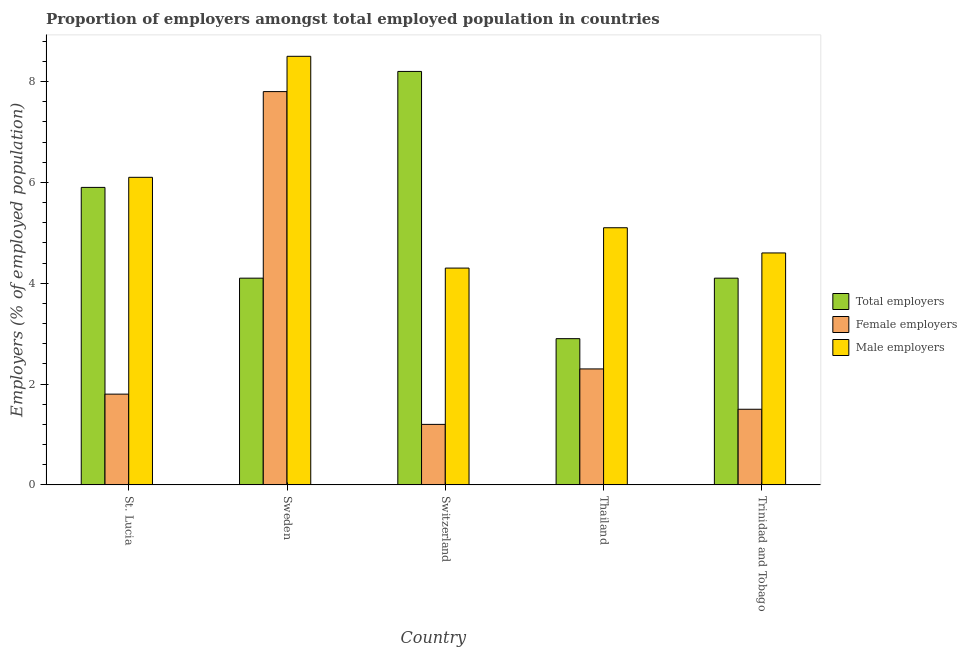How many different coloured bars are there?
Offer a very short reply. 3. Are the number of bars per tick equal to the number of legend labels?
Provide a short and direct response. Yes. How many bars are there on the 5th tick from the left?
Provide a succinct answer. 3. How many bars are there on the 4th tick from the right?
Your response must be concise. 3. What is the label of the 4th group of bars from the left?
Ensure brevity in your answer.  Thailand. In how many cases, is the number of bars for a given country not equal to the number of legend labels?
Ensure brevity in your answer.  0. What is the percentage of female employers in St. Lucia?
Your answer should be very brief. 1.8. Across all countries, what is the maximum percentage of male employers?
Provide a short and direct response. 8.5. Across all countries, what is the minimum percentage of total employers?
Offer a terse response. 2.9. In which country was the percentage of total employers minimum?
Ensure brevity in your answer.  Thailand. What is the total percentage of male employers in the graph?
Keep it short and to the point. 28.6. What is the difference between the percentage of total employers in Switzerland and that in Thailand?
Provide a short and direct response. 5.3. What is the difference between the percentage of male employers in Switzerland and the percentage of female employers in St. Lucia?
Give a very brief answer. 2.5. What is the average percentage of female employers per country?
Your answer should be very brief. 2.92. What is the difference between the percentage of male employers and percentage of female employers in Sweden?
Make the answer very short. 0.7. What is the difference between the highest and the second highest percentage of female employers?
Keep it short and to the point. 5.5. What is the difference between the highest and the lowest percentage of female employers?
Make the answer very short. 6.6. What does the 2nd bar from the left in Thailand represents?
Keep it short and to the point. Female employers. What does the 2nd bar from the right in Thailand represents?
Keep it short and to the point. Female employers. Is it the case that in every country, the sum of the percentage of total employers and percentage of female employers is greater than the percentage of male employers?
Offer a terse response. Yes. Are all the bars in the graph horizontal?
Give a very brief answer. No. How many countries are there in the graph?
Provide a short and direct response. 5. What is the difference between two consecutive major ticks on the Y-axis?
Make the answer very short. 2. Are the values on the major ticks of Y-axis written in scientific E-notation?
Give a very brief answer. No. Does the graph contain any zero values?
Keep it short and to the point. No. Where does the legend appear in the graph?
Give a very brief answer. Center right. What is the title of the graph?
Offer a terse response. Proportion of employers amongst total employed population in countries. What is the label or title of the X-axis?
Ensure brevity in your answer.  Country. What is the label or title of the Y-axis?
Your answer should be compact. Employers (% of employed population). What is the Employers (% of employed population) in Total employers in St. Lucia?
Your answer should be very brief. 5.9. What is the Employers (% of employed population) in Female employers in St. Lucia?
Offer a very short reply. 1.8. What is the Employers (% of employed population) of Male employers in St. Lucia?
Keep it short and to the point. 6.1. What is the Employers (% of employed population) of Total employers in Sweden?
Offer a terse response. 4.1. What is the Employers (% of employed population) in Female employers in Sweden?
Make the answer very short. 7.8. What is the Employers (% of employed population) in Male employers in Sweden?
Keep it short and to the point. 8.5. What is the Employers (% of employed population) in Total employers in Switzerland?
Keep it short and to the point. 8.2. What is the Employers (% of employed population) of Female employers in Switzerland?
Provide a succinct answer. 1.2. What is the Employers (% of employed population) in Male employers in Switzerland?
Offer a terse response. 4.3. What is the Employers (% of employed population) in Total employers in Thailand?
Give a very brief answer. 2.9. What is the Employers (% of employed population) in Female employers in Thailand?
Your answer should be compact. 2.3. What is the Employers (% of employed population) of Male employers in Thailand?
Offer a terse response. 5.1. What is the Employers (% of employed population) in Total employers in Trinidad and Tobago?
Provide a short and direct response. 4.1. What is the Employers (% of employed population) of Female employers in Trinidad and Tobago?
Provide a short and direct response. 1.5. What is the Employers (% of employed population) of Male employers in Trinidad and Tobago?
Provide a succinct answer. 4.6. Across all countries, what is the maximum Employers (% of employed population) of Total employers?
Provide a short and direct response. 8.2. Across all countries, what is the maximum Employers (% of employed population) in Female employers?
Ensure brevity in your answer.  7.8. Across all countries, what is the minimum Employers (% of employed population) in Total employers?
Your response must be concise. 2.9. Across all countries, what is the minimum Employers (% of employed population) of Female employers?
Provide a succinct answer. 1.2. Across all countries, what is the minimum Employers (% of employed population) in Male employers?
Your answer should be compact. 4.3. What is the total Employers (% of employed population) in Total employers in the graph?
Provide a succinct answer. 25.2. What is the total Employers (% of employed population) in Female employers in the graph?
Provide a short and direct response. 14.6. What is the total Employers (% of employed population) in Male employers in the graph?
Offer a very short reply. 28.6. What is the difference between the Employers (% of employed population) in Total employers in St. Lucia and that in Sweden?
Make the answer very short. 1.8. What is the difference between the Employers (% of employed population) of Male employers in St. Lucia and that in Sweden?
Offer a terse response. -2.4. What is the difference between the Employers (% of employed population) of Female employers in St. Lucia and that in Switzerland?
Keep it short and to the point. 0.6. What is the difference between the Employers (% of employed population) of Total employers in St. Lucia and that in Thailand?
Your answer should be compact. 3. What is the difference between the Employers (% of employed population) in Female employers in Sweden and that in Switzerland?
Your answer should be very brief. 6.6. What is the difference between the Employers (% of employed population) in Male employers in Sweden and that in Thailand?
Offer a very short reply. 3.4. What is the difference between the Employers (% of employed population) of Total employers in Sweden and that in Trinidad and Tobago?
Offer a very short reply. 0. What is the difference between the Employers (% of employed population) in Female employers in Sweden and that in Trinidad and Tobago?
Provide a succinct answer. 6.3. What is the difference between the Employers (% of employed population) in Male employers in Sweden and that in Trinidad and Tobago?
Your answer should be very brief. 3.9. What is the difference between the Employers (% of employed population) in Female employers in Switzerland and that in Thailand?
Give a very brief answer. -1.1. What is the difference between the Employers (% of employed population) in Male employers in Switzerland and that in Thailand?
Keep it short and to the point. -0.8. What is the difference between the Employers (% of employed population) of Male employers in Switzerland and that in Trinidad and Tobago?
Offer a terse response. -0.3. What is the difference between the Employers (% of employed population) of Total employers in Thailand and that in Trinidad and Tobago?
Make the answer very short. -1.2. What is the difference between the Employers (% of employed population) of Male employers in Thailand and that in Trinidad and Tobago?
Your answer should be compact. 0.5. What is the difference between the Employers (% of employed population) of Total employers in St. Lucia and the Employers (% of employed population) of Male employers in Sweden?
Provide a short and direct response. -2.6. What is the difference between the Employers (% of employed population) of Total employers in St. Lucia and the Employers (% of employed population) of Male employers in Switzerland?
Keep it short and to the point. 1.6. What is the difference between the Employers (% of employed population) of Female employers in St. Lucia and the Employers (% of employed population) of Male employers in Switzerland?
Your answer should be compact. -2.5. What is the difference between the Employers (% of employed population) in Total employers in St. Lucia and the Employers (% of employed population) in Female employers in Thailand?
Your answer should be compact. 3.6. What is the difference between the Employers (% of employed population) in Total employers in St. Lucia and the Employers (% of employed population) in Male employers in Thailand?
Keep it short and to the point. 0.8. What is the difference between the Employers (% of employed population) in Female employers in St. Lucia and the Employers (% of employed population) in Male employers in Trinidad and Tobago?
Your answer should be compact. -2.8. What is the difference between the Employers (% of employed population) of Female employers in Sweden and the Employers (% of employed population) of Male employers in Thailand?
Your answer should be very brief. 2.7. What is the difference between the Employers (% of employed population) in Total employers in Sweden and the Employers (% of employed population) in Female employers in Trinidad and Tobago?
Your response must be concise. 2.6. What is the difference between the Employers (% of employed population) of Female employers in Sweden and the Employers (% of employed population) of Male employers in Trinidad and Tobago?
Ensure brevity in your answer.  3.2. What is the difference between the Employers (% of employed population) in Total employers in Switzerland and the Employers (% of employed population) in Female employers in Thailand?
Your answer should be very brief. 5.9. What is the difference between the Employers (% of employed population) in Female employers in Switzerland and the Employers (% of employed population) in Male employers in Thailand?
Provide a short and direct response. -3.9. What is the difference between the Employers (% of employed population) in Total employers in Thailand and the Employers (% of employed population) in Female employers in Trinidad and Tobago?
Your answer should be very brief. 1.4. What is the difference between the Employers (% of employed population) of Total employers in Thailand and the Employers (% of employed population) of Male employers in Trinidad and Tobago?
Your response must be concise. -1.7. What is the difference between the Employers (% of employed population) of Female employers in Thailand and the Employers (% of employed population) of Male employers in Trinidad and Tobago?
Keep it short and to the point. -2.3. What is the average Employers (% of employed population) in Total employers per country?
Keep it short and to the point. 5.04. What is the average Employers (% of employed population) in Female employers per country?
Keep it short and to the point. 2.92. What is the average Employers (% of employed population) of Male employers per country?
Your answer should be very brief. 5.72. What is the difference between the Employers (% of employed population) of Total employers and Employers (% of employed population) of Female employers in St. Lucia?
Keep it short and to the point. 4.1. What is the difference between the Employers (% of employed population) in Female employers and Employers (% of employed population) in Male employers in St. Lucia?
Offer a very short reply. -4.3. What is the difference between the Employers (% of employed population) of Total employers and Employers (% of employed population) of Male employers in Switzerland?
Ensure brevity in your answer.  3.9. What is the difference between the Employers (% of employed population) of Female employers and Employers (% of employed population) of Male employers in Switzerland?
Provide a succinct answer. -3.1. What is the difference between the Employers (% of employed population) in Total employers and Employers (% of employed population) in Male employers in Thailand?
Offer a terse response. -2.2. What is the difference between the Employers (% of employed population) of Female employers and Employers (% of employed population) of Male employers in Thailand?
Offer a very short reply. -2.8. What is the difference between the Employers (% of employed population) of Female employers and Employers (% of employed population) of Male employers in Trinidad and Tobago?
Provide a short and direct response. -3.1. What is the ratio of the Employers (% of employed population) of Total employers in St. Lucia to that in Sweden?
Ensure brevity in your answer.  1.44. What is the ratio of the Employers (% of employed population) in Female employers in St. Lucia to that in Sweden?
Your answer should be very brief. 0.23. What is the ratio of the Employers (% of employed population) of Male employers in St. Lucia to that in Sweden?
Ensure brevity in your answer.  0.72. What is the ratio of the Employers (% of employed population) in Total employers in St. Lucia to that in Switzerland?
Give a very brief answer. 0.72. What is the ratio of the Employers (% of employed population) of Female employers in St. Lucia to that in Switzerland?
Ensure brevity in your answer.  1.5. What is the ratio of the Employers (% of employed population) in Male employers in St. Lucia to that in Switzerland?
Offer a terse response. 1.42. What is the ratio of the Employers (% of employed population) of Total employers in St. Lucia to that in Thailand?
Your response must be concise. 2.03. What is the ratio of the Employers (% of employed population) of Female employers in St. Lucia to that in Thailand?
Your answer should be compact. 0.78. What is the ratio of the Employers (% of employed population) of Male employers in St. Lucia to that in Thailand?
Ensure brevity in your answer.  1.2. What is the ratio of the Employers (% of employed population) of Total employers in St. Lucia to that in Trinidad and Tobago?
Ensure brevity in your answer.  1.44. What is the ratio of the Employers (% of employed population) in Male employers in St. Lucia to that in Trinidad and Tobago?
Your response must be concise. 1.33. What is the ratio of the Employers (% of employed population) in Total employers in Sweden to that in Switzerland?
Your answer should be very brief. 0.5. What is the ratio of the Employers (% of employed population) of Male employers in Sweden to that in Switzerland?
Give a very brief answer. 1.98. What is the ratio of the Employers (% of employed population) in Total employers in Sweden to that in Thailand?
Your answer should be compact. 1.41. What is the ratio of the Employers (% of employed population) of Female employers in Sweden to that in Thailand?
Give a very brief answer. 3.39. What is the ratio of the Employers (% of employed population) of Male employers in Sweden to that in Trinidad and Tobago?
Provide a short and direct response. 1.85. What is the ratio of the Employers (% of employed population) in Total employers in Switzerland to that in Thailand?
Make the answer very short. 2.83. What is the ratio of the Employers (% of employed population) in Female employers in Switzerland to that in Thailand?
Offer a terse response. 0.52. What is the ratio of the Employers (% of employed population) in Male employers in Switzerland to that in Thailand?
Your answer should be very brief. 0.84. What is the ratio of the Employers (% of employed population) in Total employers in Switzerland to that in Trinidad and Tobago?
Keep it short and to the point. 2. What is the ratio of the Employers (% of employed population) of Male employers in Switzerland to that in Trinidad and Tobago?
Provide a short and direct response. 0.93. What is the ratio of the Employers (% of employed population) of Total employers in Thailand to that in Trinidad and Tobago?
Ensure brevity in your answer.  0.71. What is the ratio of the Employers (% of employed population) of Female employers in Thailand to that in Trinidad and Tobago?
Offer a very short reply. 1.53. What is the ratio of the Employers (% of employed population) of Male employers in Thailand to that in Trinidad and Tobago?
Your answer should be compact. 1.11. What is the difference between the highest and the second highest Employers (% of employed population) of Female employers?
Provide a succinct answer. 5.5. What is the difference between the highest and the second highest Employers (% of employed population) in Male employers?
Ensure brevity in your answer.  2.4. What is the difference between the highest and the lowest Employers (% of employed population) in Total employers?
Your answer should be very brief. 5.3. What is the difference between the highest and the lowest Employers (% of employed population) in Female employers?
Your answer should be very brief. 6.6. 